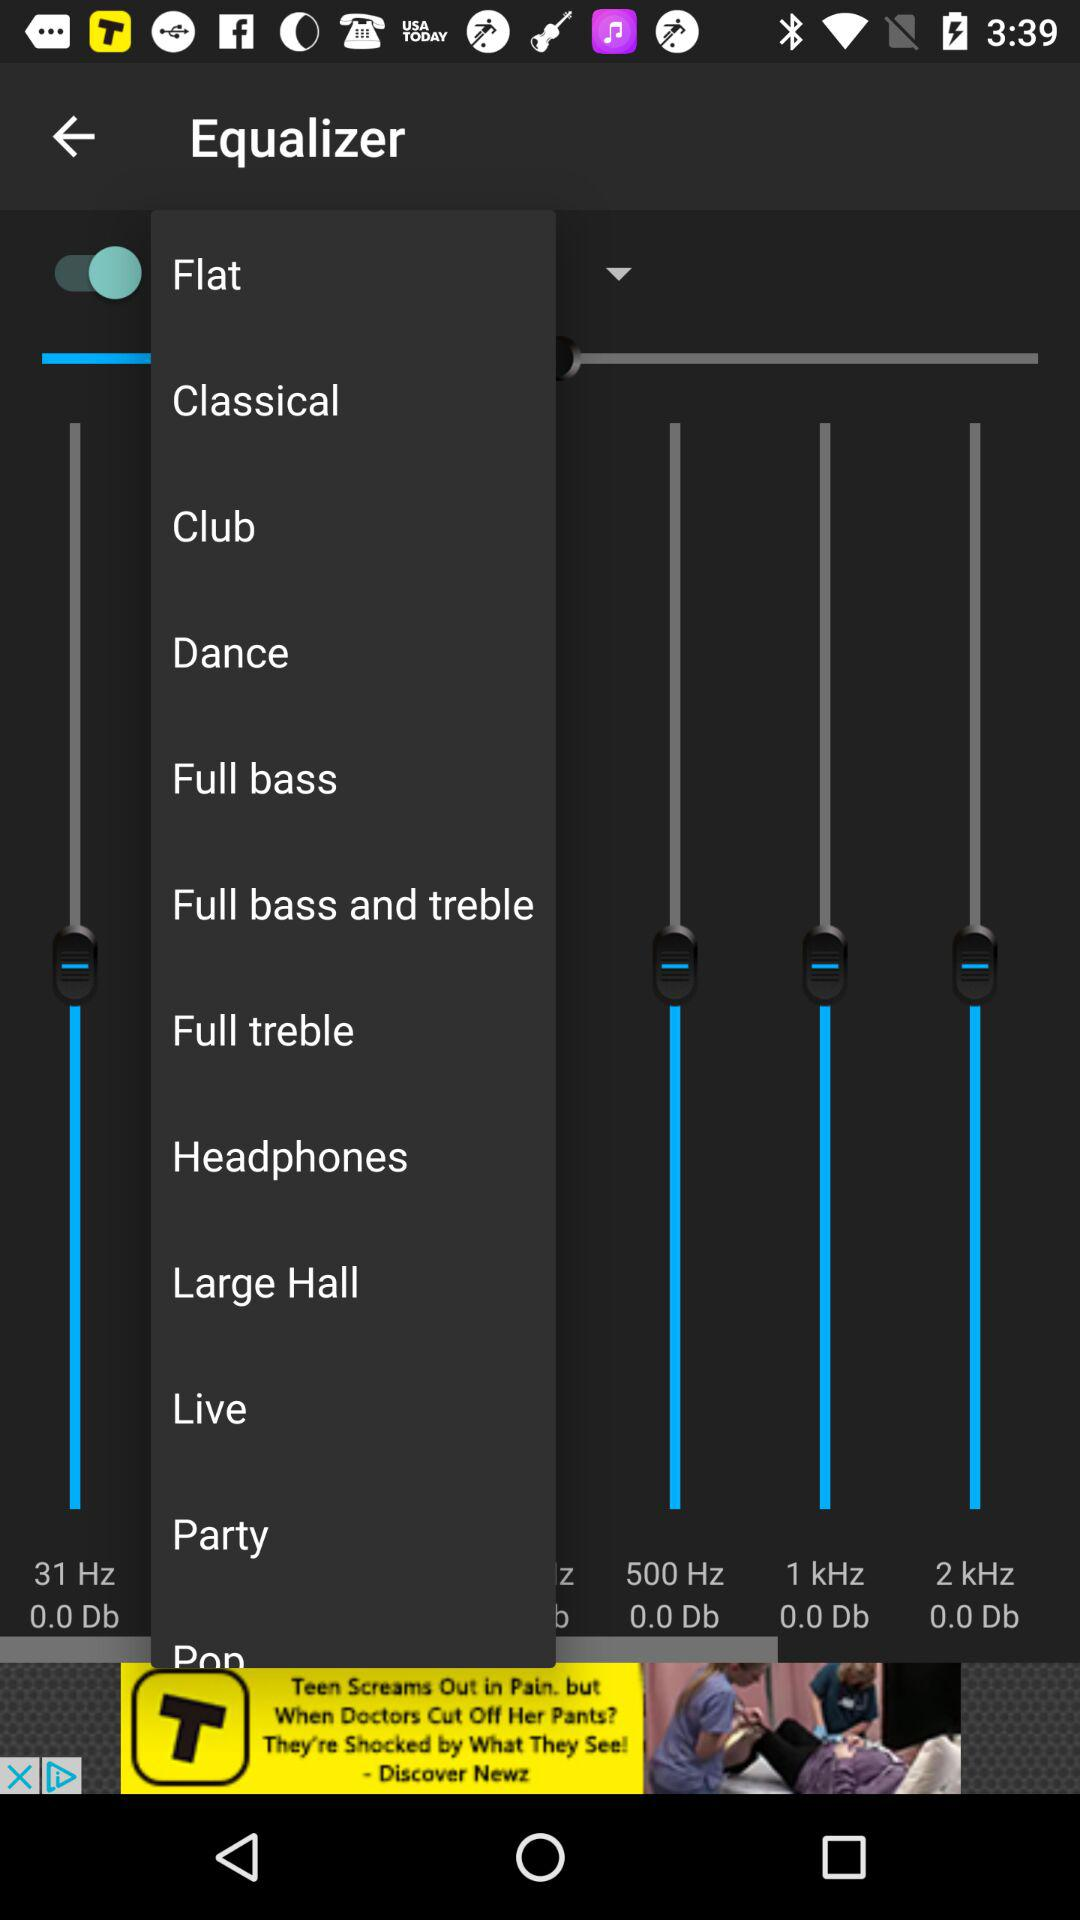What is the frequency of the lowest preset?
Answer the question using a single word or phrase. 31 Hz 